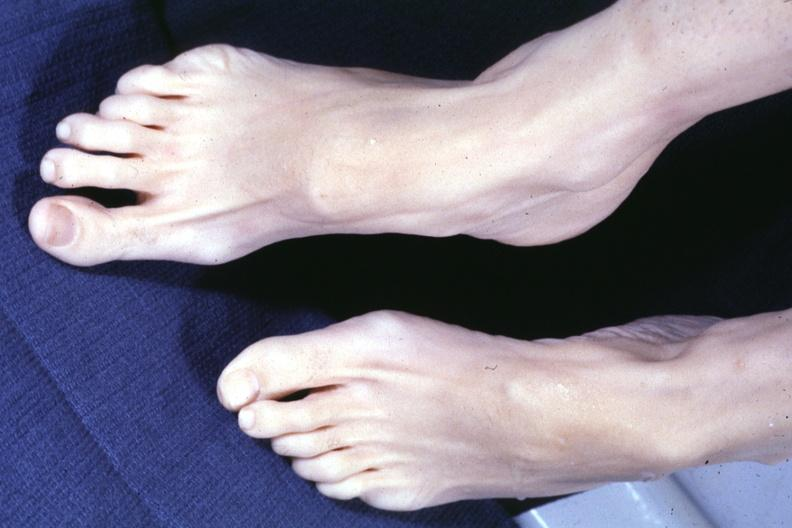what do both feet with aortic dissection and mitral prolapse extremities which suggest marfans but no cystic aortic lesions see?
Answer the question using a single word or phrase. Other slide this interesting case 